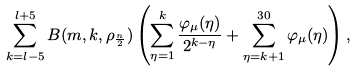<formula> <loc_0><loc_0><loc_500><loc_500>\sum _ { k = l - 5 } ^ { l + 5 } B ( m , k , \rho _ { \frac { n } { 2 } } ) \left ( \sum _ { \eta = 1 } ^ { k } \frac { \varphi _ { \mu } ( \eta ) } { 2 ^ { k - \eta } } + \sum _ { \eta = k + 1 } ^ { 3 0 } \varphi _ { \mu } ( \eta ) \right ) ,</formula> 